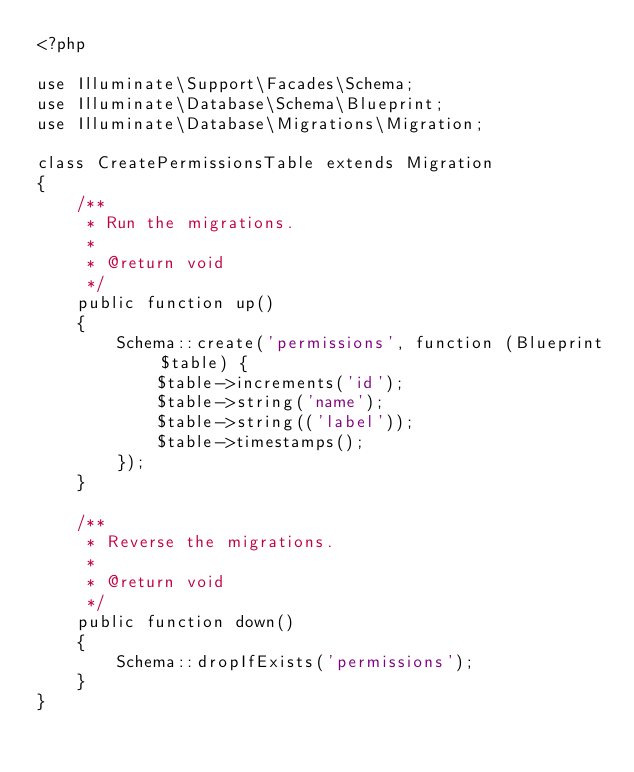Convert code to text. <code><loc_0><loc_0><loc_500><loc_500><_PHP_><?php

use Illuminate\Support\Facades\Schema;
use Illuminate\Database\Schema\Blueprint;
use Illuminate\Database\Migrations\Migration;

class CreatePermissionsTable extends Migration
{
    /**
     * Run the migrations.
     *
     * @return void
     */
    public function up()
    {
        Schema::create('permissions', function (Blueprint $table) {
            $table->increments('id');
            $table->string('name');
            $table->string(('label'));
            $table->timestamps();
        });
    }

    /**
     * Reverse the migrations.
     *
     * @return void
     */
    public function down()
    {
        Schema::dropIfExists('permissions');
    }
}
</code> 